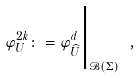<formula> <loc_0><loc_0><loc_500><loc_500>\varphi ^ { 2 k } _ { U } \colon = \varphi _ { \widehat { U } } ^ { d } \Big | _ { \mathcal { B } ( \Sigma ) } \ ,</formula> 